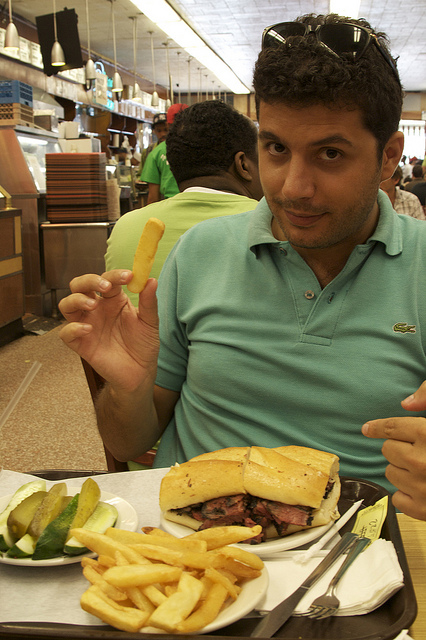<image>What kind of silverware is on his plate? There is no silverware on his plate. What kind of silverware is on his plate? I am not sure what kind of silverware is on his plate. It can be a fork and knife or knife and fork. 